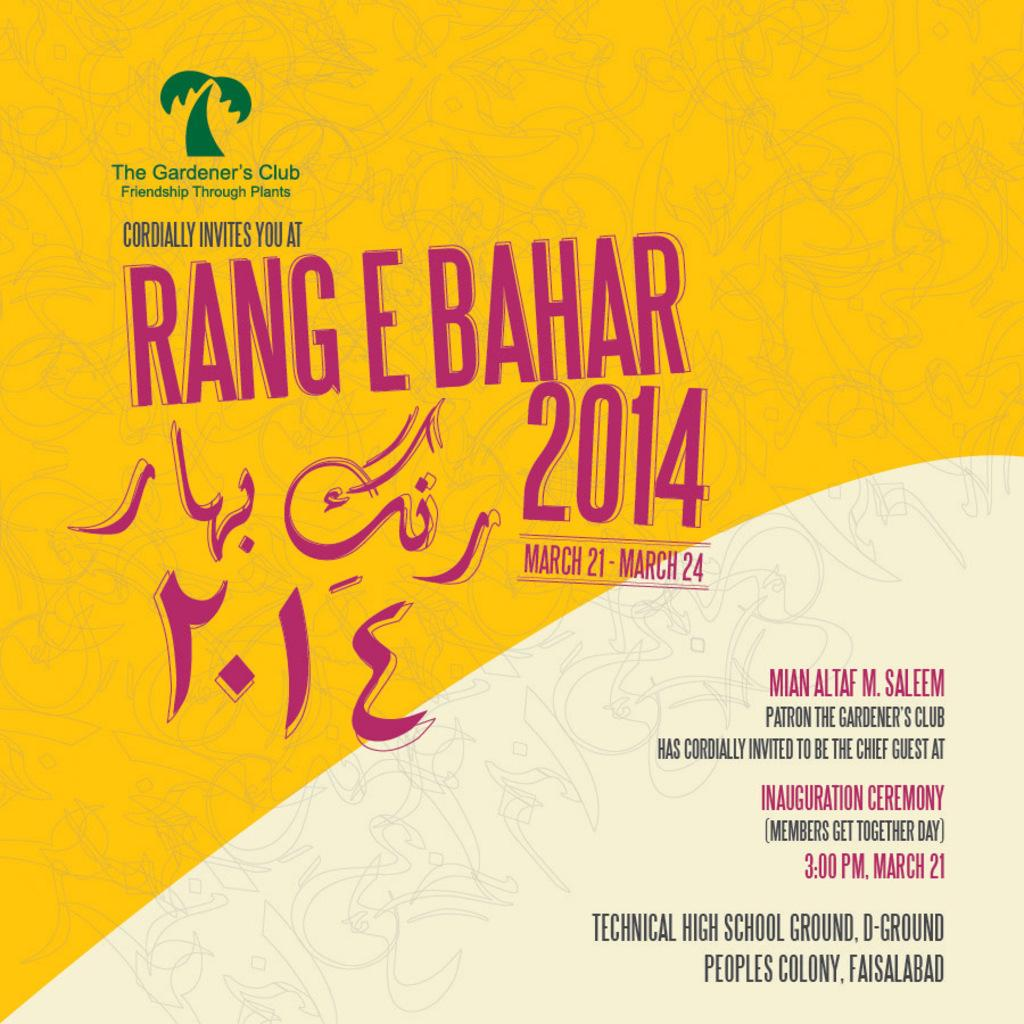<image>
Relay a brief, clear account of the picture shown. The Gardner's Club has put out an advertisement for the Rang E Bahar. 